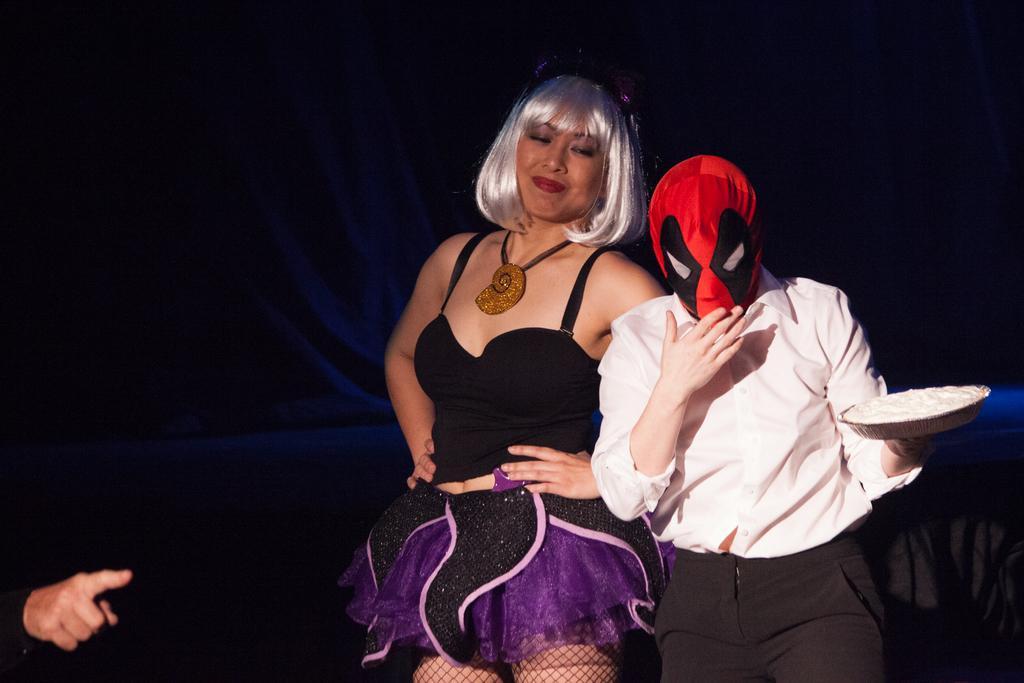In one or two sentences, can you explain what this image depicts? In this image there is a woman standing, there is a man standing, he is holding an object, he is wearing a mask, there is a person's hand towards the left of the image, at the background of the image there is a curtain. 